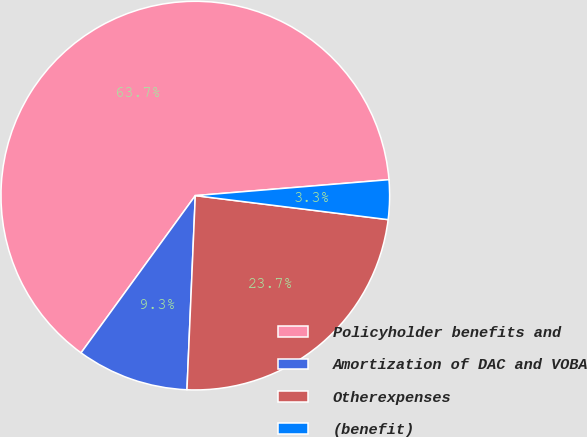<chart> <loc_0><loc_0><loc_500><loc_500><pie_chart><fcel>Policyholder benefits and<fcel>Amortization of DAC and VOBA<fcel>Otherexpenses<fcel>(benefit)<nl><fcel>63.69%<fcel>9.32%<fcel>23.71%<fcel>3.28%<nl></chart> 